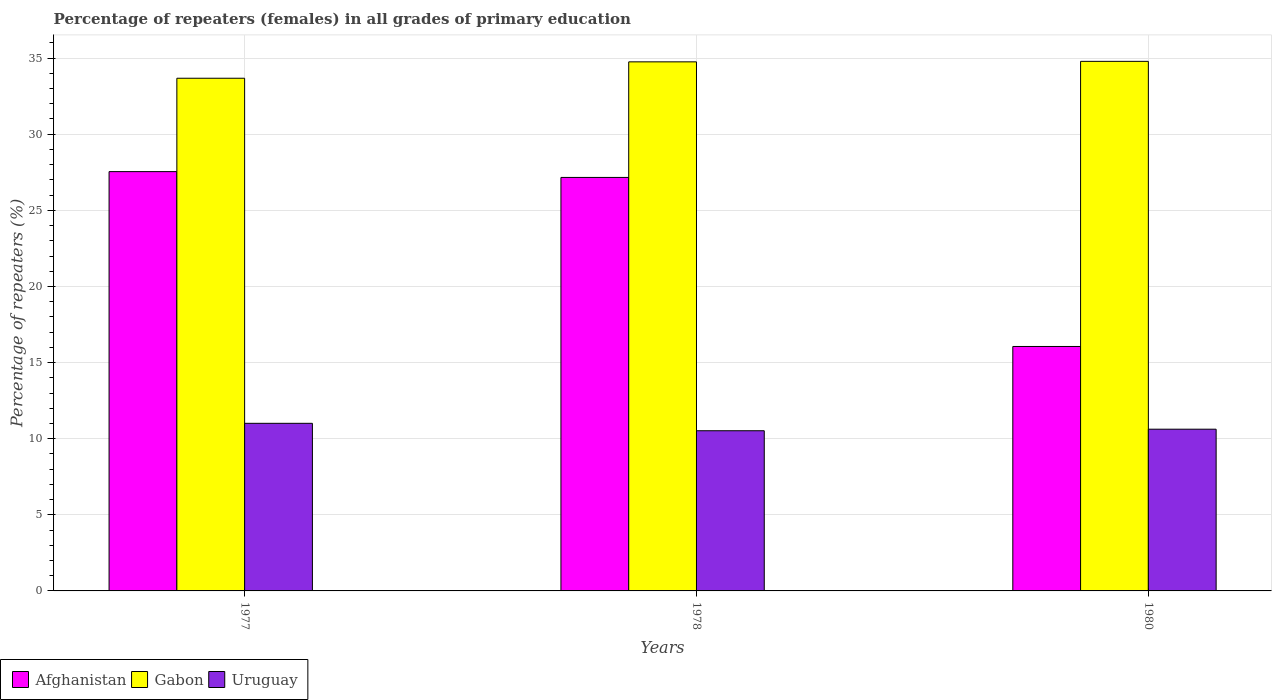How many different coloured bars are there?
Your response must be concise. 3. How many groups of bars are there?
Give a very brief answer. 3. Are the number of bars on each tick of the X-axis equal?
Make the answer very short. Yes. How many bars are there on the 2nd tick from the left?
Ensure brevity in your answer.  3. What is the percentage of repeaters (females) in Uruguay in 1978?
Make the answer very short. 10.52. Across all years, what is the maximum percentage of repeaters (females) in Uruguay?
Give a very brief answer. 11.01. Across all years, what is the minimum percentage of repeaters (females) in Uruguay?
Provide a succinct answer. 10.52. In which year was the percentage of repeaters (females) in Gabon minimum?
Make the answer very short. 1977. What is the total percentage of repeaters (females) in Uruguay in the graph?
Offer a terse response. 32.15. What is the difference between the percentage of repeaters (females) in Gabon in 1977 and that in 1978?
Make the answer very short. -1.08. What is the difference between the percentage of repeaters (females) in Gabon in 1977 and the percentage of repeaters (females) in Uruguay in 1980?
Your response must be concise. 23.05. What is the average percentage of repeaters (females) in Gabon per year?
Make the answer very short. 34.41. In the year 1978, what is the difference between the percentage of repeaters (females) in Gabon and percentage of repeaters (females) in Uruguay?
Make the answer very short. 24.23. What is the ratio of the percentage of repeaters (females) in Afghanistan in 1977 to that in 1980?
Provide a succinct answer. 1.72. Is the percentage of repeaters (females) in Uruguay in 1977 less than that in 1978?
Keep it short and to the point. No. Is the difference between the percentage of repeaters (females) in Gabon in 1978 and 1980 greater than the difference between the percentage of repeaters (females) in Uruguay in 1978 and 1980?
Offer a terse response. Yes. What is the difference between the highest and the second highest percentage of repeaters (females) in Gabon?
Your answer should be compact. 0.03. What is the difference between the highest and the lowest percentage of repeaters (females) in Gabon?
Provide a short and direct response. 1.11. In how many years, is the percentage of repeaters (females) in Uruguay greater than the average percentage of repeaters (females) in Uruguay taken over all years?
Offer a terse response. 1. What does the 3rd bar from the left in 1980 represents?
Ensure brevity in your answer.  Uruguay. What does the 2nd bar from the right in 1978 represents?
Ensure brevity in your answer.  Gabon. Is it the case that in every year, the sum of the percentage of repeaters (females) in Gabon and percentage of repeaters (females) in Uruguay is greater than the percentage of repeaters (females) in Afghanistan?
Your answer should be very brief. Yes. How many bars are there?
Your answer should be compact. 9. Are all the bars in the graph horizontal?
Make the answer very short. No. How many years are there in the graph?
Make the answer very short. 3. What is the difference between two consecutive major ticks on the Y-axis?
Ensure brevity in your answer.  5. Are the values on the major ticks of Y-axis written in scientific E-notation?
Provide a succinct answer. No. Where does the legend appear in the graph?
Your response must be concise. Bottom left. How many legend labels are there?
Give a very brief answer. 3. What is the title of the graph?
Ensure brevity in your answer.  Percentage of repeaters (females) in all grades of primary education. Does "Lesotho" appear as one of the legend labels in the graph?
Give a very brief answer. No. What is the label or title of the Y-axis?
Your answer should be compact. Percentage of repeaters (%). What is the Percentage of repeaters (%) of Afghanistan in 1977?
Keep it short and to the point. 27.54. What is the Percentage of repeaters (%) of Gabon in 1977?
Provide a succinct answer. 33.68. What is the Percentage of repeaters (%) in Uruguay in 1977?
Offer a terse response. 11.01. What is the Percentage of repeaters (%) in Afghanistan in 1978?
Offer a very short reply. 27.16. What is the Percentage of repeaters (%) in Gabon in 1978?
Provide a succinct answer. 34.75. What is the Percentage of repeaters (%) of Uruguay in 1978?
Provide a short and direct response. 10.52. What is the Percentage of repeaters (%) in Afghanistan in 1980?
Keep it short and to the point. 16.06. What is the Percentage of repeaters (%) in Gabon in 1980?
Your response must be concise. 34.79. What is the Percentage of repeaters (%) of Uruguay in 1980?
Keep it short and to the point. 10.62. Across all years, what is the maximum Percentage of repeaters (%) in Afghanistan?
Provide a succinct answer. 27.54. Across all years, what is the maximum Percentage of repeaters (%) of Gabon?
Your response must be concise. 34.79. Across all years, what is the maximum Percentage of repeaters (%) of Uruguay?
Your response must be concise. 11.01. Across all years, what is the minimum Percentage of repeaters (%) of Afghanistan?
Your answer should be compact. 16.06. Across all years, what is the minimum Percentage of repeaters (%) of Gabon?
Provide a short and direct response. 33.68. Across all years, what is the minimum Percentage of repeaters (%) in Uruguay?
Give a very brief answer. 10.52. What is the total Percentage of repeaters (%) in Afghanistan in the graph?
Make the answer very short. 70.76. What is the total Percentage of repeaters (%) of Gabon in the graph?
Your response must be concise. 103.22. What is the total Percentage of repeaters (%) of Uruguay in the graph?
Your response must be concise. 32.15. What is the difference between the Percentage of repeaters (%) in Afghanistan in 1977 and that in 1978?
Your answer should be compact. 0.38. What is the difference between the Percentage of repeaters (%) of Gabon in 1977 and that in 1978?
Ensure brevity in your answer.  -1.08. What is the difference between the Percentage of repeaters (%) of Uruguay in 1977 and that in 1978?
Your answer should be very brief. 0.49. What is the difference between the Percentage of repeaters (%) of Afghanistan in 1977 and that in 1980?
Give a very brief answer. 11.49. What is the difference between the Percentage of repeaters (%) in Gabon in 1977 and that in 1980?
Give a very brief answer. -1.11. What is the difference between the Percentage of repeaters (%) of Uruguay in 1977 and that in 1980?
Make the answer very short. 0.39. What is the difference between the Percentage of repeaters (%) of Afghanistan in 1978 and that in 1980?
Give a very brief answer. 11.1. What is the difference between the Percentage of repeaters (%) of Gabon in 1978 and that in 1980?
Provide a succinct answer. -0.03. What is the difference between the Percentage of repeaters (%) of Uruguay in 1978 and that in 1980?
Give a very brief answer. -0.1. What is the difference between the Percentage of repeaters (%) in Afghanistan in 1977 and the Percentage of repeaters (%) in Gabon in 1978?
Give a very brief answer. -7.21. What is the difference between the Percentage of repeaters (%) in Afghanistan in 1977 and the Percentage of repeaters (%) in Uruguay in 1978?
Your answer should be compact. 17.02. What is the difference between the Percentage of repeaters (%) of Gabon in 1977 and the Percentage of repeaters (%) of Uruguay in 1978?
Provide a succinct answer. 23.15. What is the difference between the Percentage of repeaters (%) of Afghanistan in 1977 and the Percentage of repeaters (%) of Gabon in 1980?
Your answer should be compact. -7.24. What is the difference between the Percentage of repeaters (%) in Afghanistan in 1977 and the Percentage of repeaters (%) in Uruguay in 1980?
Offer a terse response. 16.92. What is the difference between the Percentage of repeaters (%) of Gabon in 1977 and the Percentage of repeaters (%) of Uruguay in 1980?
Your response must be concise. 23.05. What is the difference between the Percentage of repeaters (%) in Afghanistan in 1978 and the Percentage of repeaters (%) in Gabon in 1980?
Provide a succinct answer. -7.62. What is the difference between the Percentage of repeaters (%) in Afghanistan in 1978 and the Percentage of repeaters (%) in Uruguay in 1980?
Give a very brief answer. 16.54. What is the difference between the Percentage of repeaters (%) of Gabon in 1978 and the Percentage of repeaters (%) of Uruguay in 1980?
Make the answer very short. 24.13. What is the average Percentage of repeaters (%) in Afghanistan per year?
Give a very brief answer. 23.59. What is the average Percentage of repeaters (%) of Gabon per year?
Offer a terse response. 34.41. What is the average Percentage of repeaters (%) in Uruguay per year?
Provide a succinct answer. 10.72. In the year 1977, what is the difference between the Percentage of repeaters (%) of Afghanistan and Percentage of repeaters (%) of Gabon?
Ensure brevity in your answer.  -6.13. In the year 1977, what is the difference between the Percentage of repeaters (%) of Afghanistan and Percentage of repeaters (%) of Uruguay?
Make the answer very short. 16.53. In the year 1977, what is the difference between the Percentage of repeaters (%) of Gabon and Percentage of repeaters (%) of Uruguay?
Give a very brief answer. 22.67. In the year 1978, what is the difference between the Percentage of repeaters (%) of Afghanistan and Percentage of repeaters (%) of Gabon?
Make the answer very short. -7.59. In the year 1978, what is the difference between the Percentage of repeaters (%) in Afghanistan and Percentage of repeaters (%) in Uruguay?
Keep it short and to the point. 16.64. In the year 1978, what is the difference between the Percentage of repeaters (%) in Gabon and Percentage of repeaters (%) in Uruguay?
Provide a short and direct response. 24.23. In the year 1980, what is the difference between the Percentage of repeaters (%) in Afghanistan and Percentage of repeaters (%) in Gabon?
Your answer should be compact. -18.73. In the year 1980, what is the difference between the Percentage of repeaters (%) in Afghanistan and Percentage of repeaters (%) in Uruguay?
Offer a very short reply. 5.43. In the year 1980, what is the difference between the Percentage of repeaters (%) in Gabon and Percentage of repeaters (%) in Uruguay?
Provide a succinct answer. 24.16. What is the ratio of the Percentage of repeaters (%) in Afghanistan in 1977 to that in 1978?
Your answer should be compact. 1.01. What is the ratio of the Percentage of repeaters (%) in Uruguay in 1977 to that in 1978?
Offer a terse response. 1.05. What is the ratio of the Percentage of repeaters (%) in Afghanistan in 1977 to that in 1980?
Keep it short and to the point. 1.72. What is the ratio of the Percentage of repeaters (%) of Gabon in 1977 to that in 1980?
Offer a terse response. 0.97. What is the ratio of the Percentage of repeaters (%) in Uruguay in 1977 to that in 1980?
Offer a terse response. 1.04. What is the ratio of the Percentage of repeaters (%) in Afghanistan in 1978 to that in 1980?
Keep it short and to the point. 1.69. What is the ratio of the Percentage of repeaters (%) in Gabon in 1978 to that in 1980?
Ensure brevity in your answer.  1. What is the difference between the highest and the second highest Percentage of repeaters (%) of Afghanistan?
Your response must be concise. 0.38. What is the difference between the highest and the second highest Percentage of repeaters (%) of Gabon?
Your answer should be very brief. 0.03. What is the difference between the highest and the second highest Percentage of repeaters (%) of Uruguay?
Give a very brief answer. 0.39. What is the difference between the highest and the lowest Percentage of repeaters (%) in Afghanistan?
Your answer should be very brief. 11.49. What is the difference between the highest and the lowest Percentage of repeaters (%) of Gabon?
Your answer should be compact. 1.11. What is the difference between the highest and the lowest Percentage of repeaters (%) of Uruguay?
Make the answer very short. 0.49. 